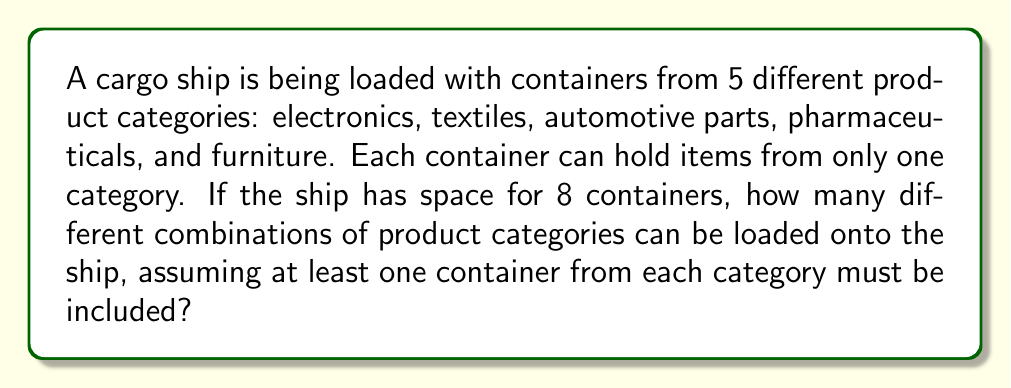Teach me how to tackle this problem. Let's approach this step-by-step:

1) First, we need to understand that this is a combination with repetition problem, but with a constraint that at least one container from each category must be included.

2) To solve this, we can use the "stars and bars" method, but we need to account for the constraint.

3) We start by allocating one container to each category, which uses up 5 containers:
   $$(1, 1, 1, 1, 1)$$

4) Now we have 3 containers left to distribute among the 5 categories.

5) This becomes a standard stars and bars problem. We need to find the number of ways to put 3 identical objects (remaining containers) into 5 distinct boxes (product categories).

6) The formula for this is:

   $$\binom{n+k-1}{k} = \binom{5+3-1}{3} = \binom{7}{3}$$

   Where $n$ is the number of boxes (5 categories) and $k$ is the number of objects to distribute (3 remaining containers).

7) We can calculate this:

   $$\binom{7}{3} = \frac{7!}{3!(7-3)!} = \frac{7!}{3!4!} = \frac{7 \cdot 6 \cdot 5}{3 \cdot 2 \cdot 1} = 35$$

Therefore, there are 35 different ways to distribute the remaining 3 containers among the 5 categories.
Answer: 35 combinations 